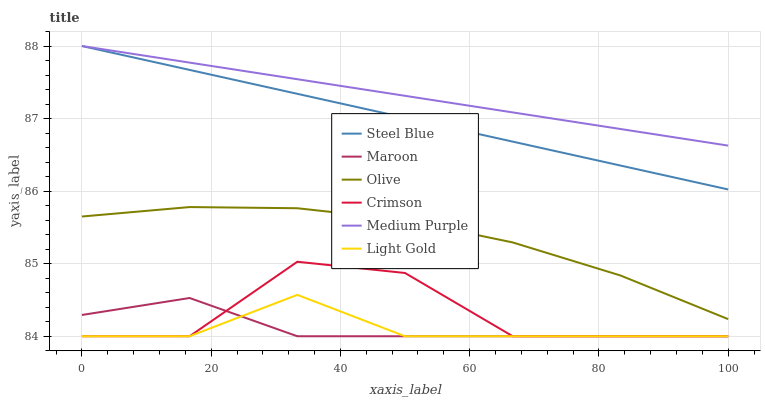Does Light Gold have the minimum area under the curve?
Answer yes or no. Yes. Does Medium Purple have the maximum area under the curve?
Answer yes or no. Yes. Does Maroon have the minimum area under the curve?
Answer yes or no. No. Does Maroon have the maximum area under the curve?
Answer yes or no. No. Is Medium Purple the smoothest?
Answer yes or no. Yes. Is Crimson the roughest?
Answer yes or no. Yes. Is Maroon the smoothest?
Answer yes or no. No. Is Maroon the roughest?
Answer yes or no. No. Does Maroon have the lowest value?
Answer yes or no. Yes. Does Medium Purple have the lowest value?
Answer yes or no. No. Does Medium Purple have the highest value?
Answer yes or no. Yes. Does Maroon have the highest value?
Answer yes or no. No. Is Crimson less than Medium Purple?
Answer yes or no. Yes. Is Olive greater than Maroon?
Answer yes or no. Yes. Does Crimson intersect Maroon?
Answer yes or no. Yes. Is Crimson less than Maroon?
Answer yes or no. No. Is Crimson greater than Maroon?
Answer yes or no. No. Does Crimson intersect Medium Purple?
Answer yes or no. No. 